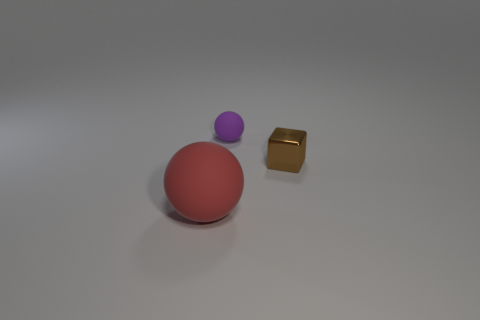Add 2 purple spheres. How many objects exist? 5 Subtract all spheres. How many objects are left? 1 Subtract 0 red blocks. How many objects are left? 3 Subtract all big balls. Subtract all red things. How many objects are left? 1 Add 3 small cubes. How many small cubes are left? 4 Add 3 spheres. How many spheres exist? 5 